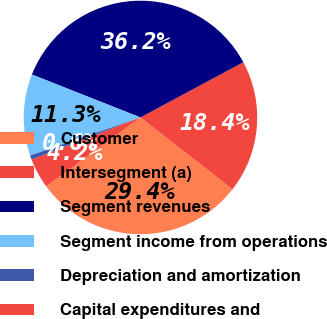Convert chart. <chart><loc_0><loc_0><loc_500><loc_500><pie_chart><fcel>Customer<fcel>Intersegment (a)<fcel>Segment revenues<fcel>Segment income from operations<fcel>Depreciation and amortization<fcel>Capital expenditures and<nl><fcel>29.4%<fcel>18.39%<fcel>36.17%<fcel>11.28%<fcel>0.61%<fcel>4.16%<nl></chart> 